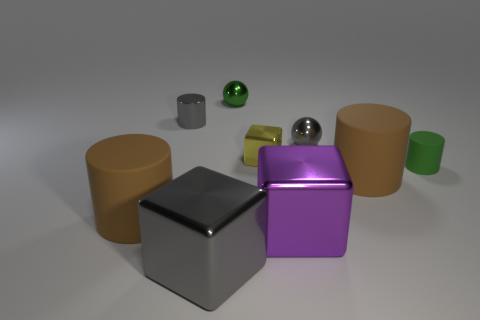Is the size of the shiny cylinder the same as the gray metallic object that is to the right of the gray shiny cube?
Provide a short and direct response. Yes. What number of things are either metallic cylinders or green cylinders?
Offer a terse response. 2. How many other objects are the same size as the green metal object?
Your answer should be very brief. 4. Does the metallic cylinder have the same color as the cube that is left of the yellow metallic object?
Offer a very short reply. Yes. How many blocks are tiny red rubber objects or yellow shiny things?
Your answer should be very brief. 1. Are there any other things of the same color as the metal cylinder?
Provide a short and direct response. Yes. There is a cylinder that is behind the yellow shiny object to the left of the small gray shiny sphere; what is its material?
Offer a very short reply. Metal. Is the purple thing made of the same material as the small gray thing on the left side of the tiny yellow thing?
Provide a succinct answer. Yes. How many things are either gray objects in front of the tiny green rubber cylinder or metal cylinders?
Provide a succinct answer. 2. Are there any tiny objects of the same color as the shiny cylinder?
Provide a succinct answer. Yes. 